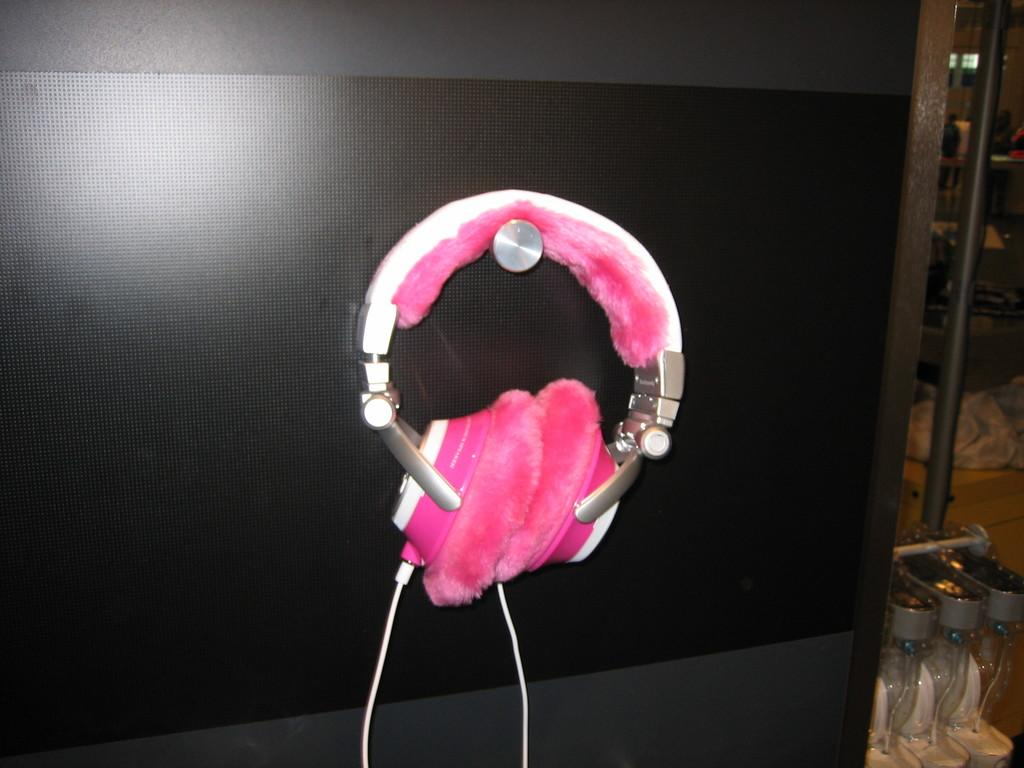What type of device is present in the image? There are headphones in the image. What is connected to the headphones? There is a cable in the image. What can be seen in the background of the image? There are objects visible in the background of the image. What structures are present in the image? There is a wall and a pole in the image. What type of kettle is visible in the image? There is no kettle present in the image. How many family members can be seen in the image? There is no family present in the image. 